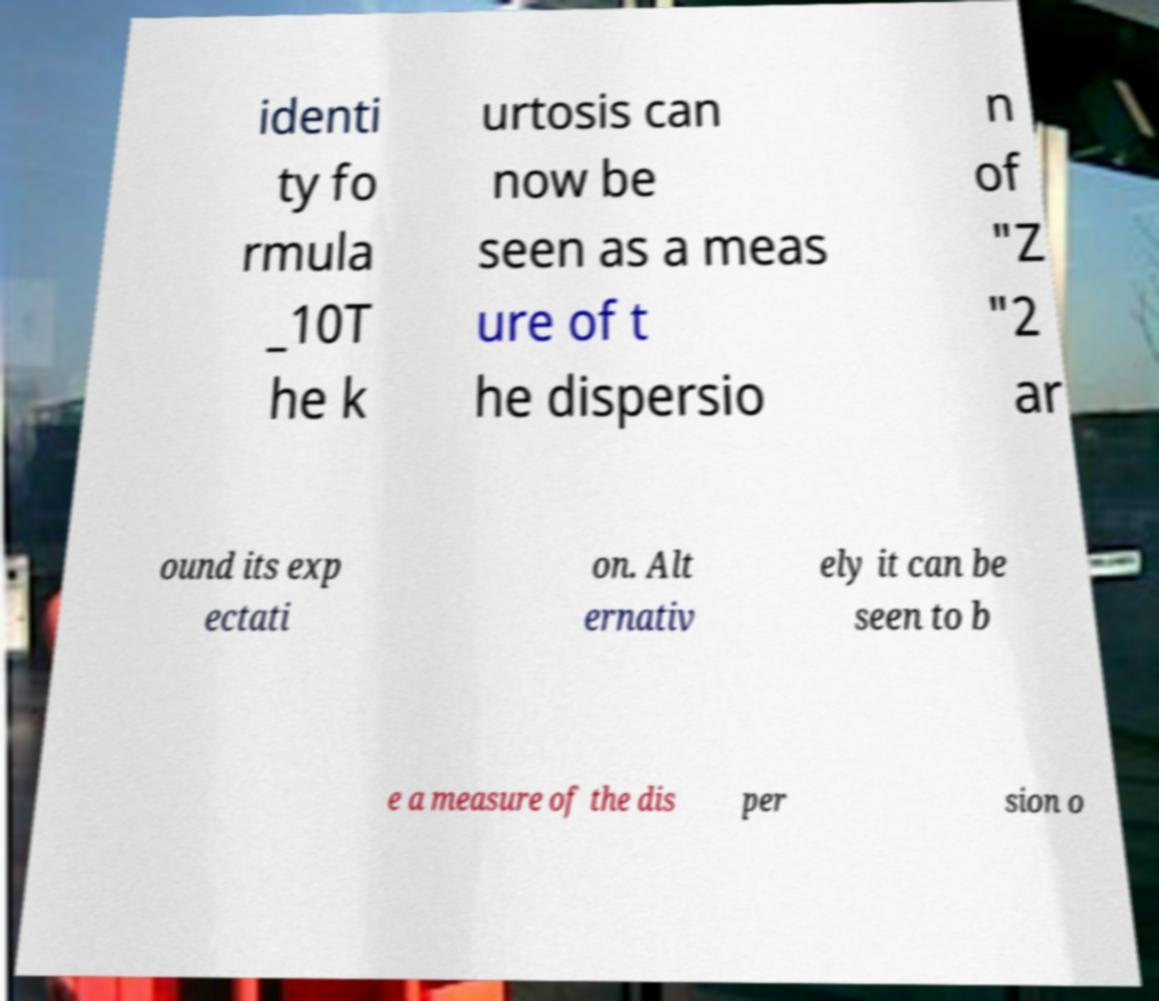Could you extract and type out the text from this image? identi ty fo rmula _10T he k urtosis can now be seen as a meas ure of t he dispersio n of "Z "2 ar ound its exp ectati on. Alt ernativ ely it can be seen to b e a measure of the dis per sion o 